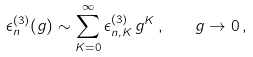Convert formula to latex. <formula><loc_0><loc_0><loc_500><loc_500>\epsilon ^ { ( 3 ) } _ { n } ( g ) \sim \sum _ { K = 0 } ^ { \infty } \epsilon ^ { ( 3 ) } _ { n , K } \, g ^ { K } \, , \quad g \to 0 \, ,</formula> 